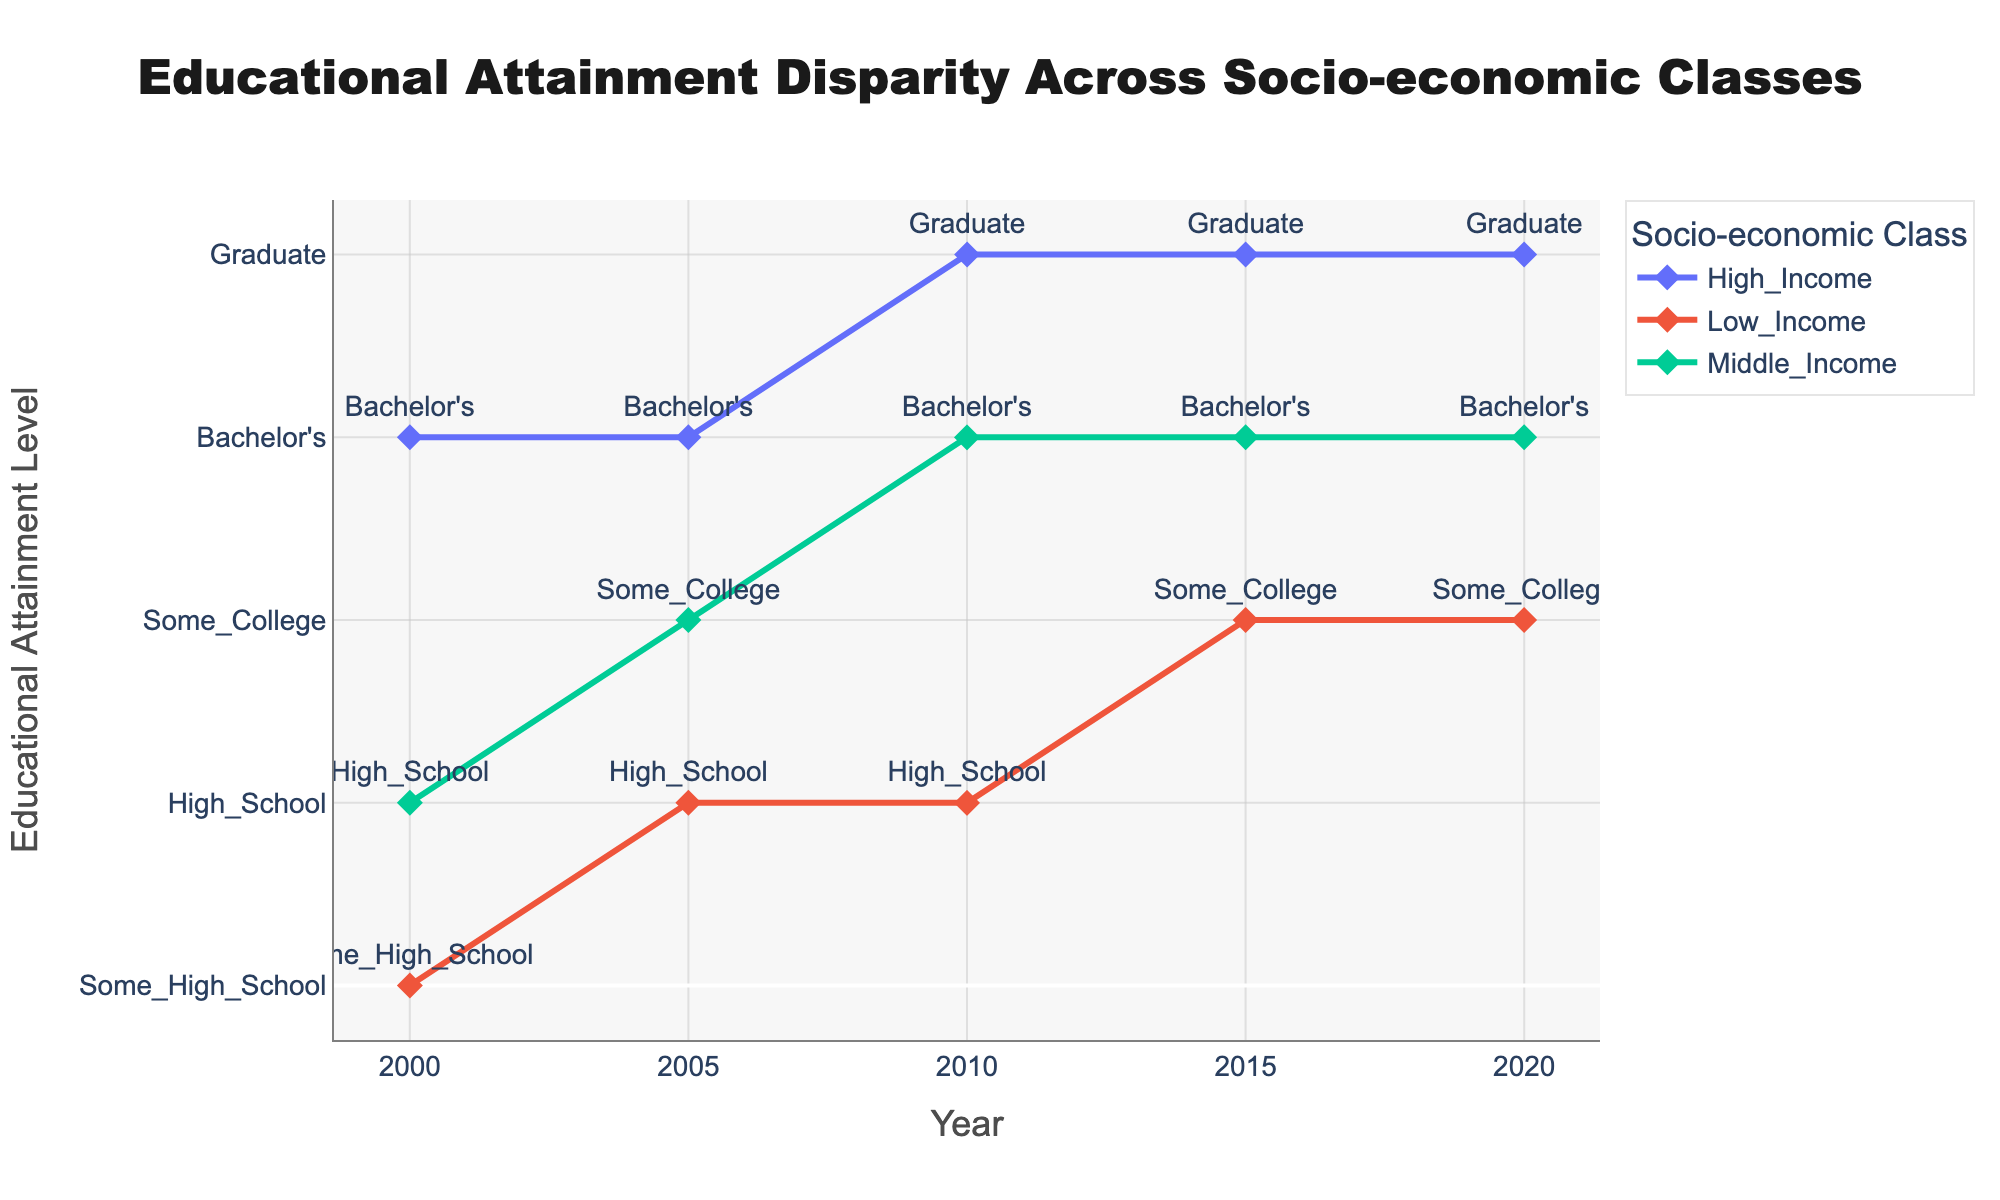What is the title of the plot? The title can be found at the top center of the plot. It reads "Educational Attainment Disparity Across Socio-economic Classes".
Answer: Educational Attainment Disparity Across Socio-economic Classes Which socio-economic class consistently has the highest educational attainment level from 2000 to 2020? The plot shows three lines, each representing a socio-economic class. The "High_Income" class consistently has the highest educational attainment level as indicated by the top-most line for each year.
Answer: High_Income In what year did the "Middle_Income" class first attain a Bachelor's education level? Observing the "Middle_Income" class line, the label changes to "Bachelor's" in the year 2010.
Answer: 2010 How many distinct educational attainment levels are shown throughout the years? There is a vertical axis label listing the distinct educational attainment levels: 'Some_High_School', 'High_School', 'Some_College', "Bachelor's", and 'Graduate'. These are five levels altogether.
Answer: 5 What is the change in educational attainment level for the "Low_Income" class between 2000 and 2020? In 2000, the "Low_Income" class is at 'Some_High_School', and by 2020 they reach 'Some_College'. This shows an increase from 0 to 2 on the categorical education scale.
Answer: Some_High_School to Some_College Which year shows the largest educational attainment disparity between "High_Income" and "Low_Income" classes? Checking the vertical distance between the lines for "High_Income" and "Low_Income" for each year, the year 2000 shows the greatest disparity with "High_Income" at 'Bachelor's' and "Low_Income" at 'Some_High_School'.
Answer: 2000 By how many levels did the "Low_Income" class's educational attainment increase from 2000 to 2020? The "Low_Income" class moved from 'Some_High_School' (a score of 0) in 2000 to 'Some_College' (a score of 2) in 2020. Thus, the increase is 2 levels.
Answer: 2 Which socio-economic class shows the most dramatic improvement in educational attainment over the observed period? Examining the vertical changes in the lines, the "Middle_Income" class shows a dramatic improvement from 'High_School' in 2000 to 'Bachelor's' in 2020.
Answer: Middle_Income In 2015, what is the educational attainment level for the "Middle_Income" class? For the year 2015, the label for the "Middle_Income" line is 'Bachelor's'.
Answer: Bachelor's 